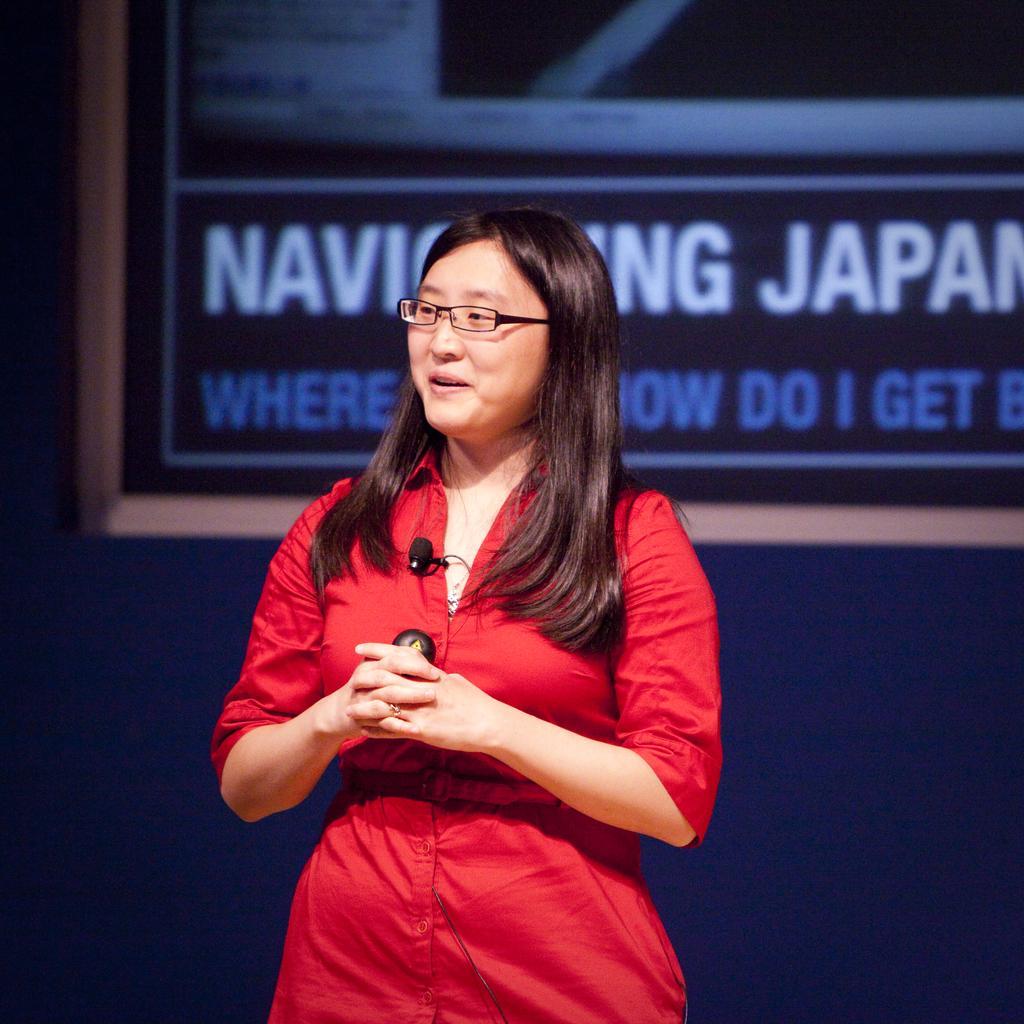Could you give a brief overview of what you see in this image? Here we can see a woman. She is smiling and she has spectacles. In the background we can see a board. 